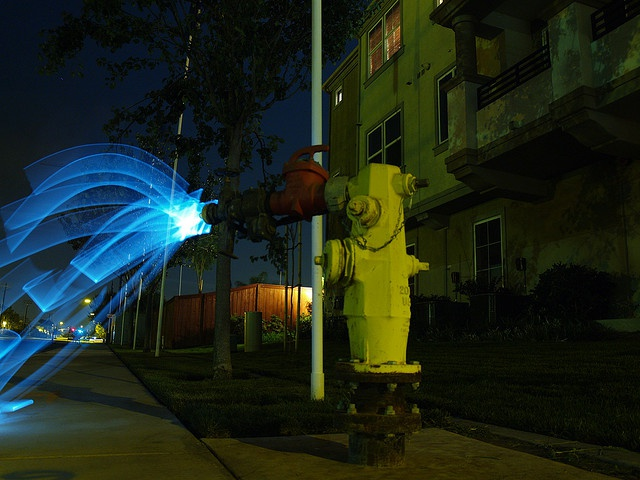Describe the objects in this image and their specific colors. I can see a fire hydrant in black, olive, and darkgreen tones in this image. 